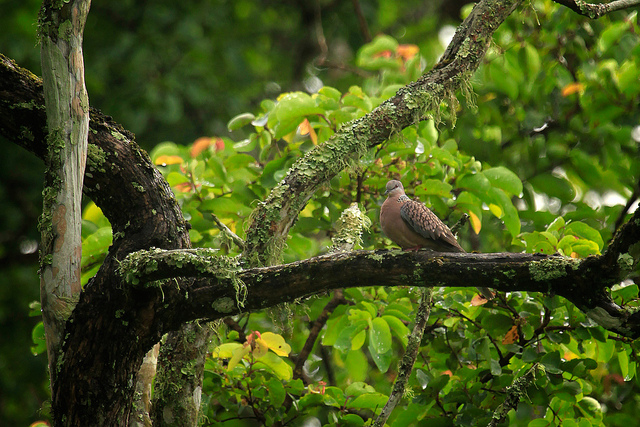<image>What species of bird is this? I don't know the species of the bird. It could be a sparrow, a fowl, a dove, a pigeon, or a partridge. What kind of bird is this? I don't know what kind of bird it is. It could be a pigeon, pheasant, dove, or robin. What species of bird is this? I don't know the species of bird in the image. It can be seen as sparrow, fowl, dove, pigeon, or partridge. What kind of bird is this? I don't know what kind of bird it is. It can be seen as a pigeon, pheasant, dove, robin, or any other kind of bird. 